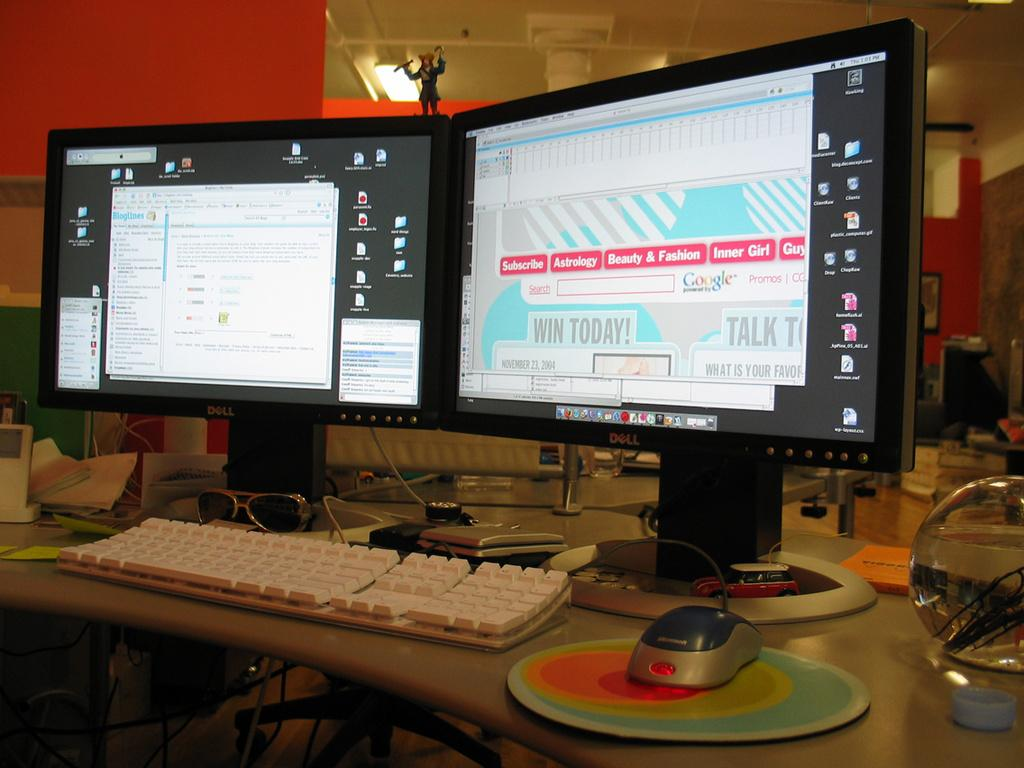<image>
Render a clear and concise summary of the photo. Two computer screens are on a desk, one is showing a page that says "Win Today!" 